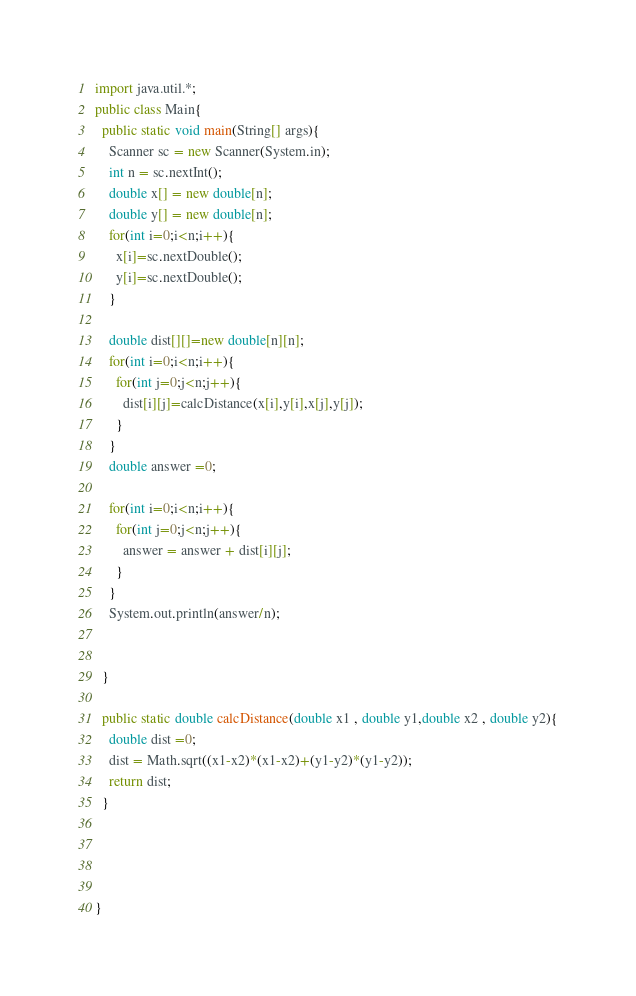Convert code to text. <code><loc_0><loc_0><loc_500><loc_500><_Java_>import java.util.*;
public class Main{
  public static void main(String[] args){
    Scanner sc = new Scanner(System.in);
    int n = sc.nextInt();
    double x[] = new double[n];
    double y[] = new double[n];
    for(int i=0;i<n;i++){
      x[i]=sc.nextDouble();
      y[i]=sc.nextDouble();
    }
    
    double dist[][]=new double[n][n];
    for(int i=0;i<n;i++){
      for(int j=0;j<n;j++){
        dist[i][j]=calcDistance(x[i],y[i],x[j],y[j]);
      }
    }
    double answer =0;
    
    for(int i=0;i<n;i++){
      for(int j=0;j<n;j++){
        answer = answer + dist[i][j];
      }
    }
    System.out.println(answer/n);
    
    
  }
  
  public static double calcDistance(double x1 , double y1,double x2 , double y2){
    double dist =0;
    dist = Math.sqrt((x1-x2)*(x1-x2)+(y1-y2)*(y1-y2));
    return dist;
  }
    
  

  
}</code> 